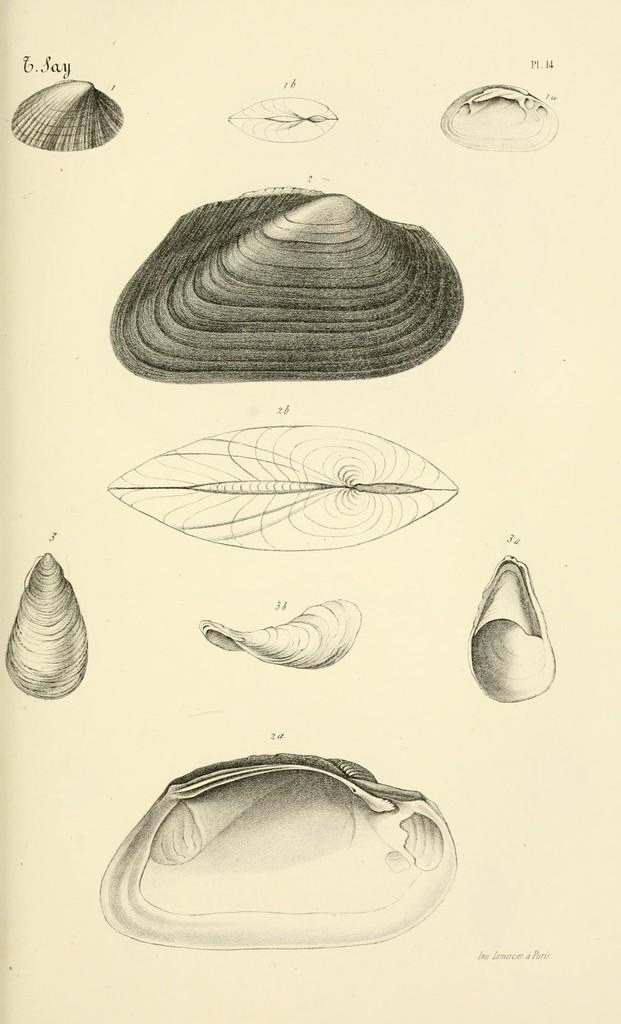What medium is used for the artwork in the image? The image is a painting on paper. What is the main subject of the painting? The painting depicts a leaf. Are there any other elements in the painting besides the leaf? Yes, the painting also includes stones. What type of cough medicine is depicted in the painting? There is no cough medicine present in the painting; it features a leaf and stones. 